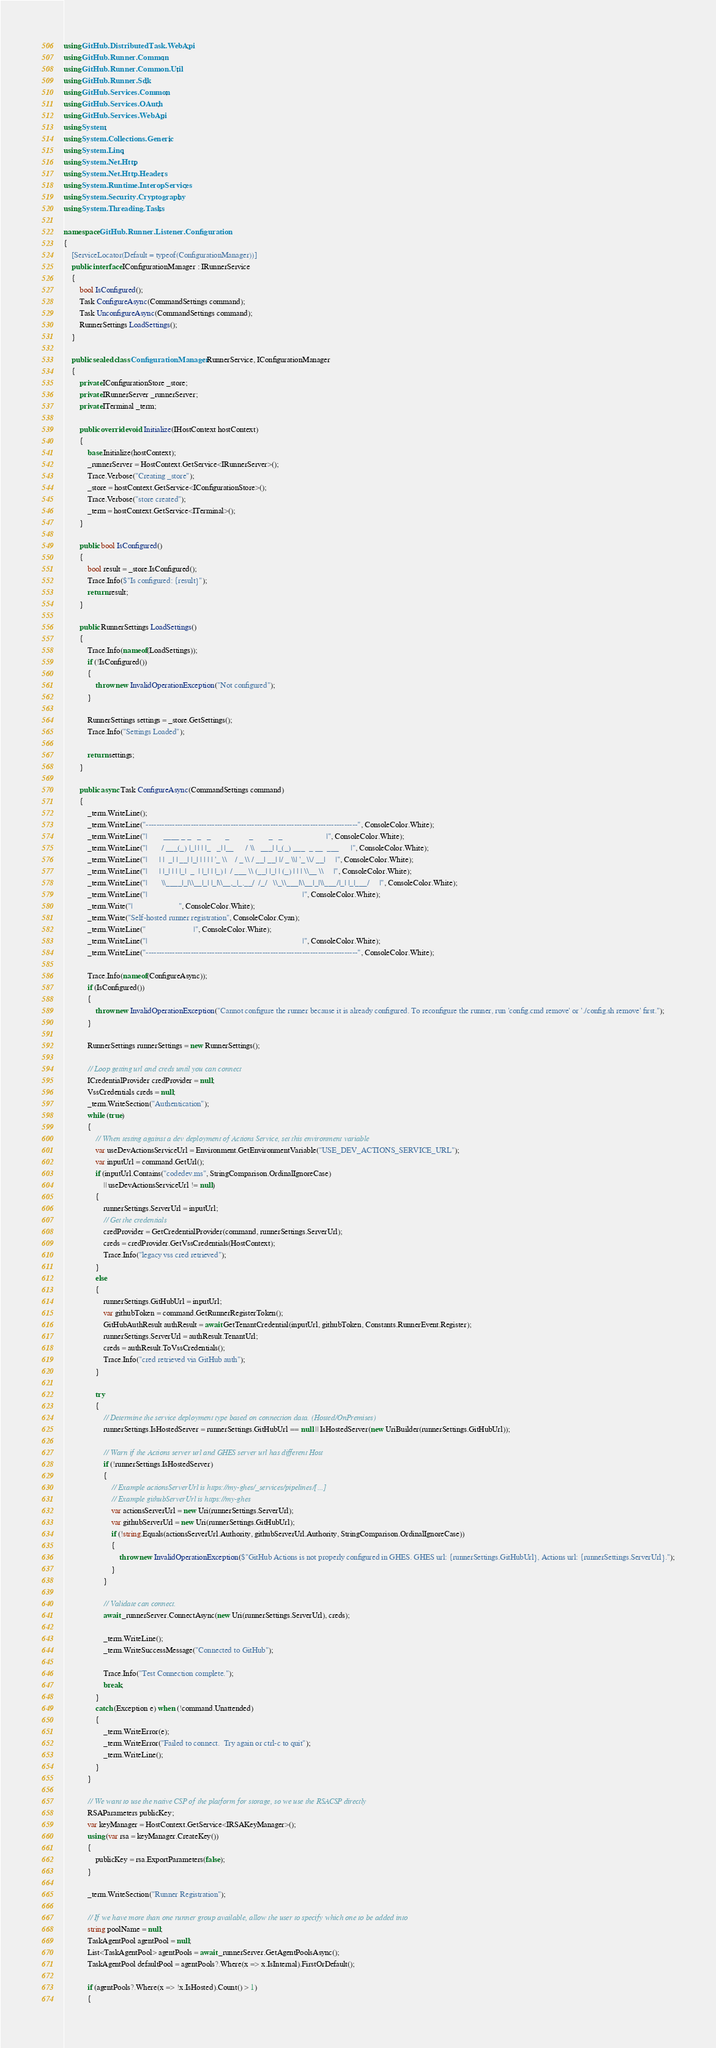Convert code to text. <code><loc_0><loc_0><loc_500><loc_500><_C#_>using GitHub.DistributedTask.WebApi;
using GitHub.Runner.Common;
using GitHub.Runner.Common.Util;
using GitHub.Runner.Sdk;
using GitHub.Services.Common;
using GitHub.Services.OAuth;
using GitHub.Services.WebApi;
using System;
using System.Collections.Generic;
using System.Linq;
using System.Net.Http;
using System.Net.Http.Headers;
using System.Runtime.InteropServices;
using System.Security.Cryptography;
using System.Threading.Tasks;

namespace GitHub.Runner.Listener.Configuration
{
    [ServiceLocator(Default = typeof(ConfigurationManager))]
    public interface IConfigurationManager : IRunnerService
    {
        bool IsConfigured();
        Task ConfigureAsync(CommandSettings command);
        Task UnconfigureAsync(CommandSettings command);
        RunnerSettings LoadSettings();
    }

    public sealed class ConfigurationManager : RunnerService, IConfigurationManager
    {
        private IConfigurationStore _store;
        private IRunnerServer _runnerServer;
        private ITerminal _term;

        public override void Initialize(IHostContext hostContext)
        {
            base.Initialize(hostContext);
            _runnerServer = HostContext.GetService<IRunnerServer>();
            Trace.Verbose("Creating _store");
            _store = hostContext.GetService<IConfigurationStore>();
            Trace.Verbose("store created");
            _term = hostContext.GetService<ITerminal>();
        }

        public bool IsConfigured()
        {
            bool result = _store.IsConfigured();
            Trace.Info($"Is configured: {result}");
            return result;
        }

        public RunnerSettings LoadSettings()
        {
            Trace.Info(nameof(LoadSettings));
            if (!IsConfigured())
            {
                throw new InvalidOperationException("Not configured");
            }

            RunnerSettings settings = _store.GetSettings();
            Trace.Info("Settings Loaded");

            return settings;
        }

        public async Task ConfigureAsync(CommandSettings command)
        {
            _term.WriteLine();
            _term.WriteLine("--------------------------------------------------------------------------------", ConsoleColor.White);
            _term.WriteLine("|        ____ _ _   _   _       _          _        _   _                      |", ConsoleColor.White);
            _term.WriteLine("|       / ___(_) |_| | | |_   _| |__      / \\   ___| |_(_) ___  _ __  ___      |", ConsoleColor.White);
            _term.WriteLine("|      | |  _| | __| |_| | | | | '_ \\    / _ \\ / __| __| |/ _ \\| '_ \\/ __|     |", ConsoleColor.White);
            _term.WriteLine("|      | |_| | | |_|  _  | |_| | |_) |  / ___ \\ (__| |_| | (_) | | | \\__ \\     |", ConsoleColor.White);
            _term.WriteLine("|       \\____|_|\\__|_| |_|\\__,_|_.__/  /_/   \\_\\___|\\__|_|\\___/|_| |_|___/     |", ConsoleColor.White);
            _term.WriteLine("|                                                                              |", ConsoleColor.White);
            _term.Write("|                       ", ConsoleColor.White);
            _term.Write("Self-hosted runner registration", ConsoleColor.Cyan);
            _term.WriteLine("                        |", ConsoleColor.White);
            _term.WriteLine("|                                                                              |", ConsoleColor.White);
            _term.WriteLine("--------------------------------------------------------------------------------", ConsoleColor.White);

            Trace.Info(nameof(ConfigureAsync));
            if (IsConfigured())
            {
                throw new InvalidOperationException("Cannot configure the runner because it is already configured. To reconfigure the runner, run 'config.cmd remove' or './config.sh remove' first.");
            }

            RunnerSettings runnerSettings = new RunnerSettings();

            // Loop getting url and creds until you can connect
            ICredentialProvider credProvider = null;
            VssCredentials creds = null;
            _term.WriteSection("Authentication");
            while (true)
            {
                // When testing against a dev deployment of Actions Service, set this environment variable
                var useDevActionsServiceUrl = Environment.GetEnvironmentVariable("USE_DEV_ACTIONS_SERVICE_URL");
                var inputUrl = command.GetUrl();
                if (inputUrl.Contains("codedev.ms", StringComparison.OrdinalIgnoreCase)
                    || useDevActionsServiceUrl != null)
                {
                    runnerSettings.ServerUrl = inputUrl;
                    // Get the credentials
                    credProvider = GetCredentialProvider(command, runnerSettings.ServerUrl);
                    creds = credProvider.GetVssCredentials(HostContext);
                    Trace.Info("legacy vss cred retrieved");
                }
                else
                {
                    runnerSettings.GitHubUrl = inputUrl;
                    var githubToken = command.GetRunnerRegisterToken();
                    GitHubAuthResult authResult = await GetTenantCredential(inputUrl, githubToken, Constants.RunnerEvent.Register);
                    runnerSettings.ServerUrl = authResult.TenantUrl;
                    creds = authResult.ToVssCredentials();
                    Trace.Info("cred retrieved via GitHub auth");
                }

                try
                {
                    // Determine the service deployment type based on connection data. (Hosted/OnPremises)
                    runnerSettings.IsHostedServer = runnerSettings.GitHubUrl == null || IsHostedServer(new UriBuilder(runnerSettings.GitHubUrl));

                    // Warn if the Actions server url and GHES server url has different Host
                    if (!runnerSettings.IsHostedServer)
                    {
                        // Example actionsServerUrl is https://my-ghes/_services/pipelines/[...]
                        // Example githubServerUrl is https://my-ghes
                        var actionsServerUrl = new Uri(runnerSettings.ServerUrl);
                        var githubServerUrl = new Uri(runnerSettings.GitHubUrl);
                        if (!string.Equals(actionsServerUrl.Authority, githubServerUrl.Authority, StringComparison.OrdinalIgnoreCase))
                        {
                            throw new InvalidOperationException($"GitHub Actions is not properly configured in GHES. GHES url: {runnerSettings.GitHubUrl}, Actions url: {runnerSettings.ServerUrl}.");
                        }
                    }

                    // Validate can connect.
                    await _runnerServer.ConnectAsync(new Uri(runnerSettings.ServerUrl), creds);

                    _term.WriteLine();
                    _term.WriteSuccessMessage("Connected to GitHub");

                    Trace.Info("Test Connection complete.");
                    break;
                }
                catch (Exception e) when (!command.Unattended)
                {
                    _term.WriteError(e);
                    _term.WriteError("Failed to connect.  Try again or ctrl-c to quit");
                    _term.WriteLine();
                }
            }

            // We want to use the native CSP of the platform for storage, so we use the RSACSP directly
            RSAParameters publicKey;
            var keyManager = HostContext.GetService<IRSAKeyManager>();
            using (var rsa = keyManager.CreateKey())
            {
                publicKey = rsa.ExportParameters(false);
            }

            _term.WriteSection("Runner Registration");

            // If we have more than one runner group available, allow the user to specify which one to be added into
            string poolName = null;
            TaskAgentPool agentPool = null;
            List<TaskAgentPool> agentPools = await _runnerServer.GetAgentPoolsAsync();
            TaskAgentPool defaultPool = agentPools?.Where(x => x.IsInternal).FirstOrDefault();

            if (agentPools?.Where(x => !x.IsHosted).Count() > 1)
            {</code> 